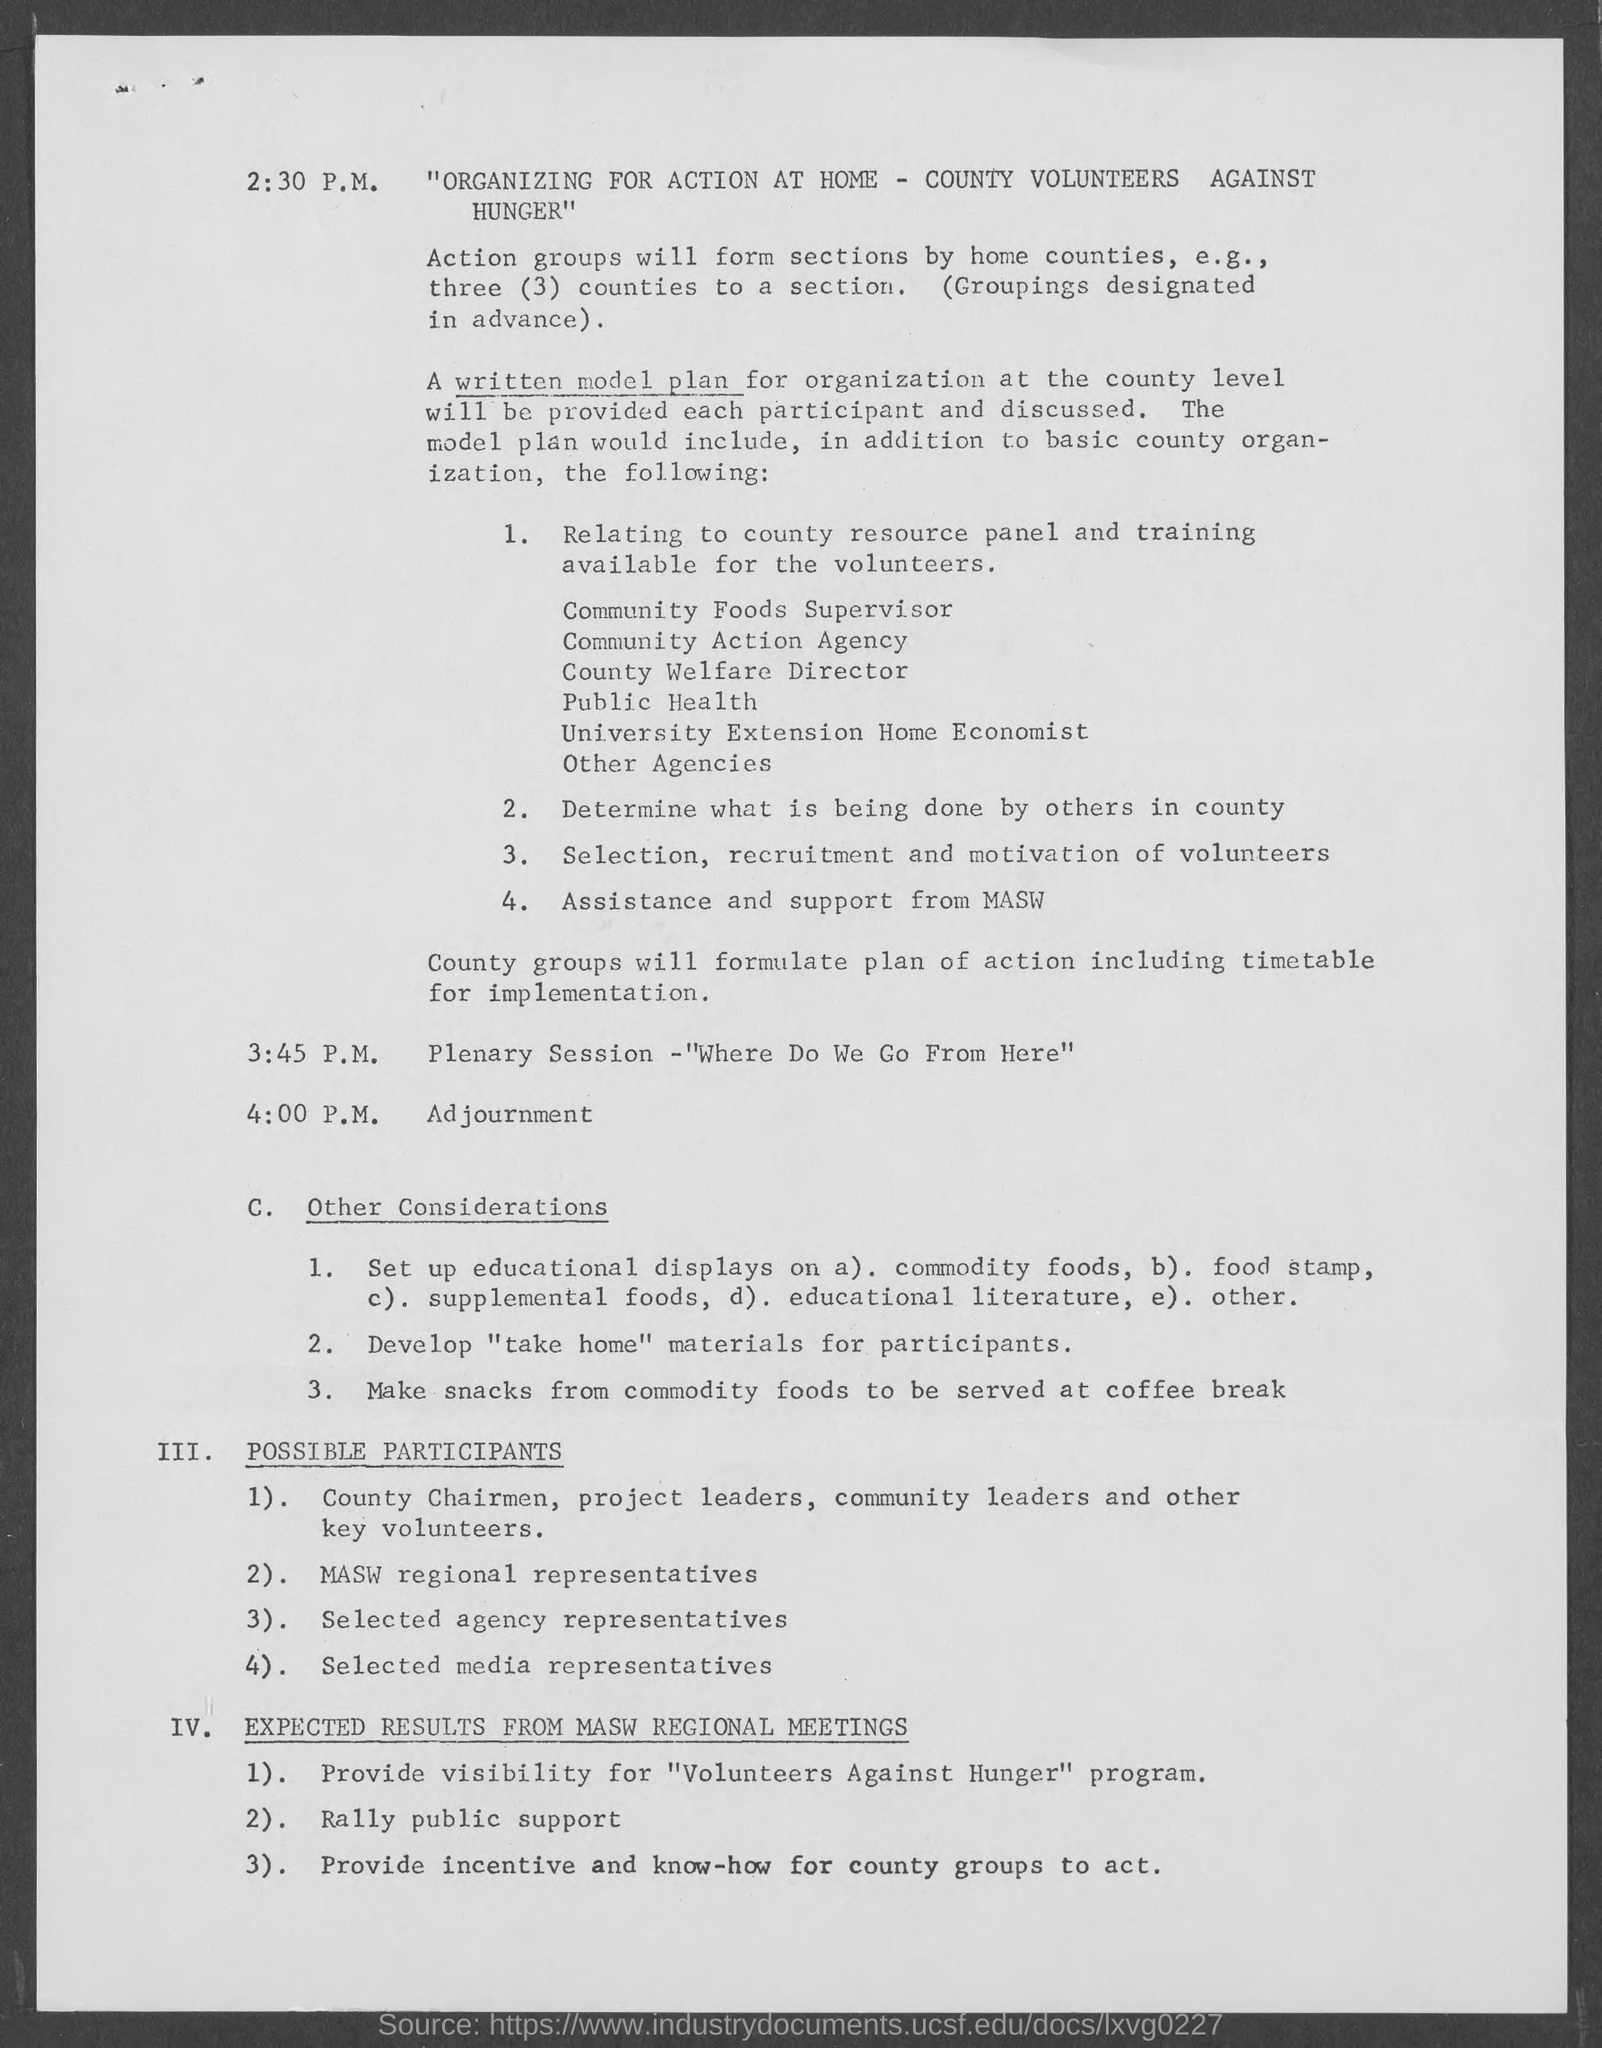Highlight a few significant elements in this photo. The adjournment is scheduled for 4:00 PM. The plenary session is scheduled to take place at 3:45 p.m.. 